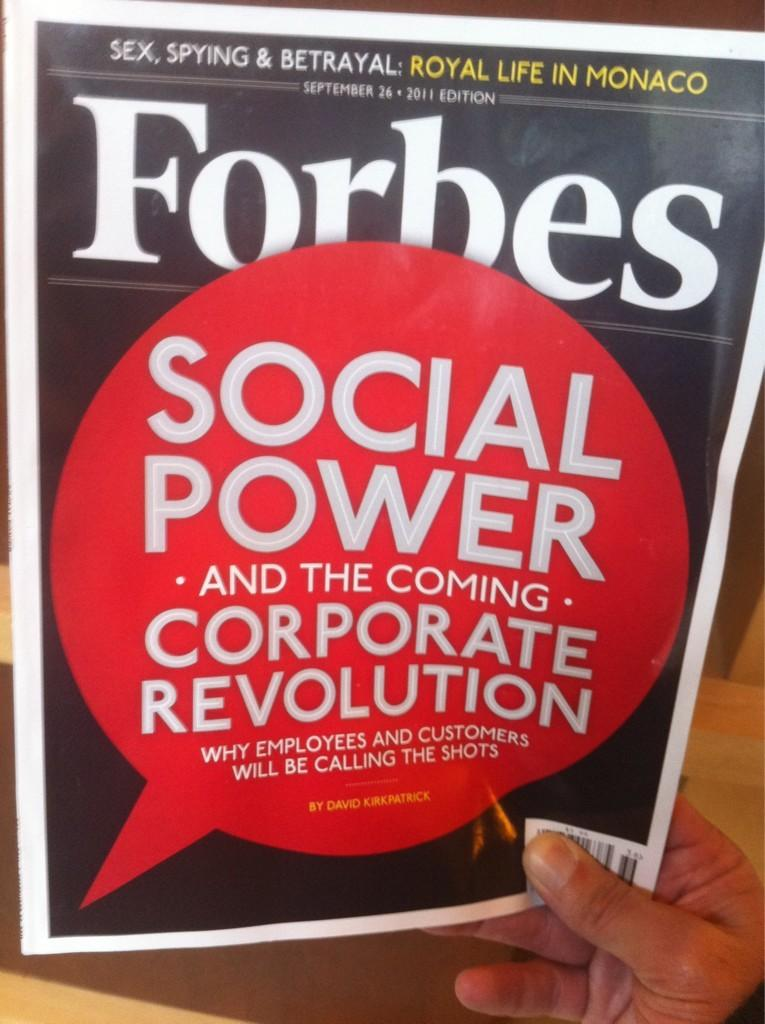<image>
Share a concise interpretation of the image provided. Forbes magazine cover about social power and the coming corporate revolution. 